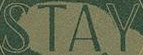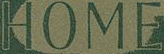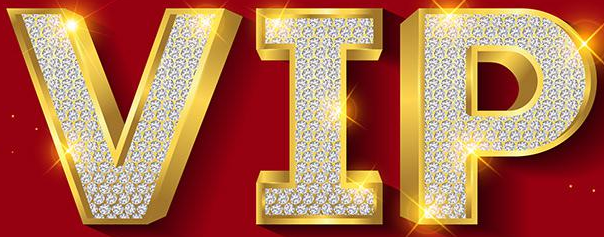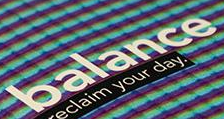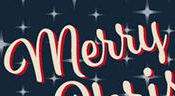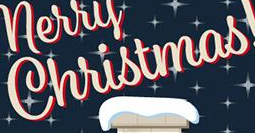What words are shown in these images in order, separated by a semicolon? STAY; HOME; VIP; balance; merry; Christmas 